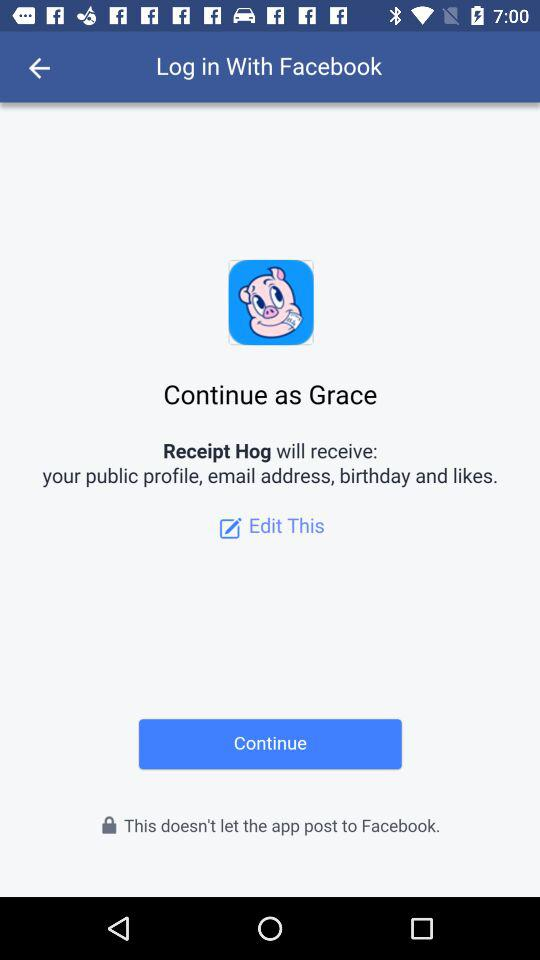What application is asking for permission? The application asking for permission is "Receipt Hog". 